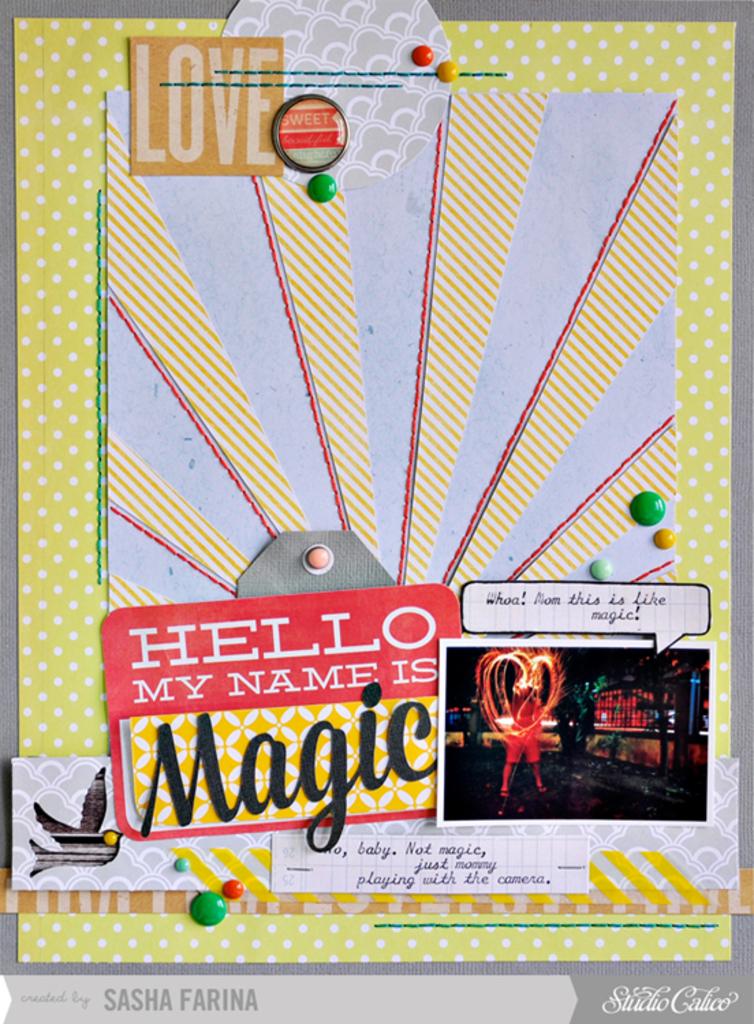What is his name?
Your response must be concise. Magic. What emotion is cites on the poster?
Keep it short and to the point. Love. 